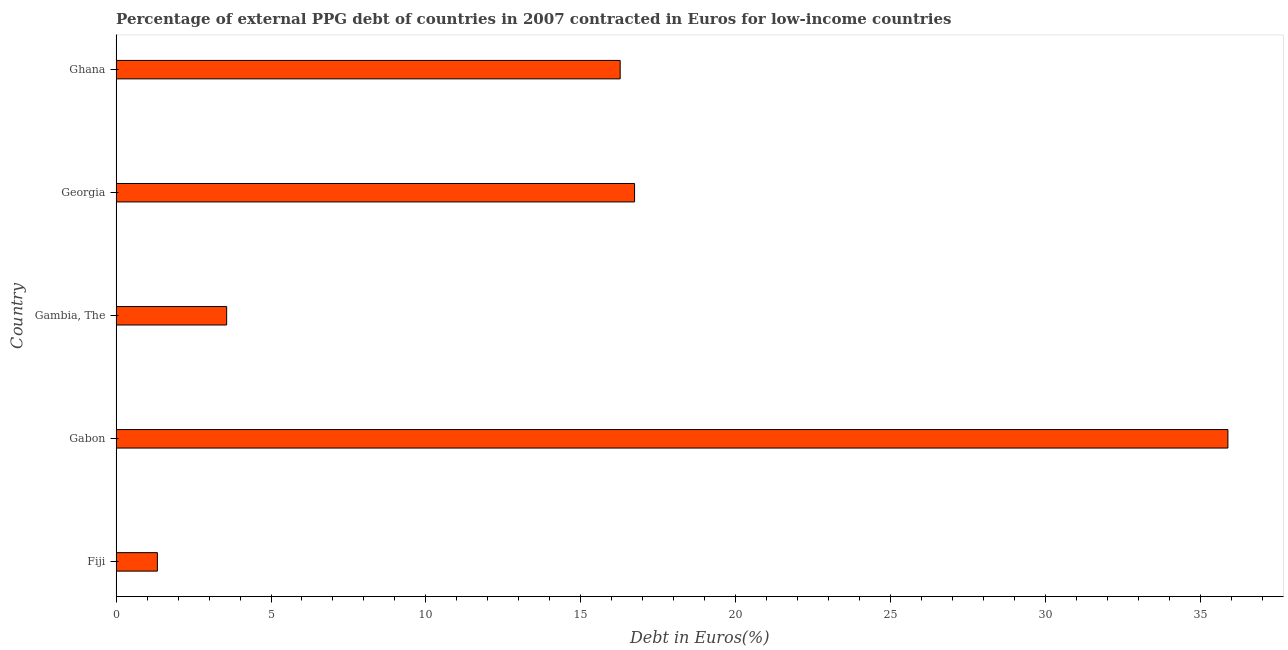Does the graph contain grids?
Provide a short and direct response. No. What is the title of the graph?
Offer a terse response. Percentage of external PPG debt of countries in 2007 contracted in Euros for low-income countries. What is the label or title of the X-axis?
Your answer should be compact. Debt in Euros(%). What is the currency composition of ppg debt in Georgia?
Offer a very short reply. 16.74. Across all countries, what is the maximum currency composition of ppg debt?
Make the answer very short. 35.89. Across all countries, what is the minimum currency composition of ppg debt?
Provide a succinct answer. 1.33. In which country was the currency composition of ppg debt maximum?
Make the answer very short. Gabon. In which country was the currency composition of ppg debt minimum?
Offer a very short reply. Fiji. What is the sum of the currency composition of ppg debt?
Your answer should be very brief. 73.8. What is the difference between the currency composition of ppg debt in Fiji and Gabon?
Ensure brevity in your answer.  -34.56. What is the average currency composition of ppg debt per country?
Give a very brief answer. 14.76. What is the median currency composition of ppg debt?
Make the answer very short. 16.27. What is the difference between the highest and the second highest currency composition of ppg debt?
Your answer should be very brief. 19.16. What is the difference between the highest and the lowest currency composition of ppg debt?
Offer a very short reply. 34.56. In how many countries, is the currency composition of ppg debt greater than the average currency composition of ppg debt taken over all countries?
Provide a short and direct response. 3. How many countries are there in the graph?
Offer a terse response. 5. What is the Debt in Euros(%) in Fiji?
Offer a terse response. 1.33. What is the Debt in Euros(%) of Gabon?
Your response must be concise. 35.89. What is the Debt in Euros(%) in Gambia, The?
Your answer should be compact. 3.57. What is the Debt in Euros(%) of Georgia?
Ensure brevity in your answer.  16.74. What is the Debt in Euros(%) in Ghana?
Your answer should be very brief. 16.27. What is the difference between the Debt in Euros(%) in Fiji and Gabon?
Your response must be concise. -34.56. What is the difference between the Debt in Euros(%) in Fiji and Gambia, The?
Give a very brief answer. -2.24. What is the difference between the Debt in Euros(%) in Fiji and Georgia?
Your answer should be very brief. -15.41. What is the difference between the Debt in Euros(%) in Fiji and Ghana?
Provide a succinct answer. -14.94. What is the difference between the Debt in Euros(%) in Gabon and Gambia, The?
Your answer should be very brief. 32.32. What is the difference between the Debt in Euros(%) in Gabon and Georgia?
Your answer should be very brief. 19.16. What is the difference between the Debt in Euros(%) in Gabon and Ghana?
Provide a short and direct response. 19.62. What is the difference between the Debt in Euros(%) in Gambia, The and Georgia?
Keep it short and to the point. -13.17. What is the difference between the Debt in Euros(%) in Gambia, The and Ghana?
Keep it short and to the point. -12.7. What is the difference between the Debt in Euros(%) in Georgia and Ghana?
Give a very brief answer. 0.47. What is the ratio of the Debt in Euros(%) in Fiji to that in Gabon?
Offer a terse response. 0.04. What is the ratio of the Debt in Euros(%) in Fiji to that in Gambia, The?
Your answer should be very brief. 0.37. What is the ratio of the Debt in Euros(%) in Fiji to that in Georgia?
Offer a very short reply. 0.08. What is the ratio of the Debt in Euros(%) in Fiji to that in Ghana?
Ensure brevity in your answer.  0.08. What is the ratio of the Debt in Euros(%) in Gabon to that in Gambia, The?
Provide a succinct answer. 10.06. What is the ratio of the Debt in Euros(%) in Gabon to that in Georgia?
Provide a succinct answer. 2.14. What is the ratio of the Debt in Euros(%) in Gabon to that in Ghana?
Keep it short and to the point. 2.21. What is the ratio of the Debt in Euros(%) in Gambia, The to that in Georgia?
Keep it short and to the point. 0.21. What is the ratio of the Debt in Euros(%) in Gambia, The to that in Ghana?
Give a very brief answer. 0.22. 